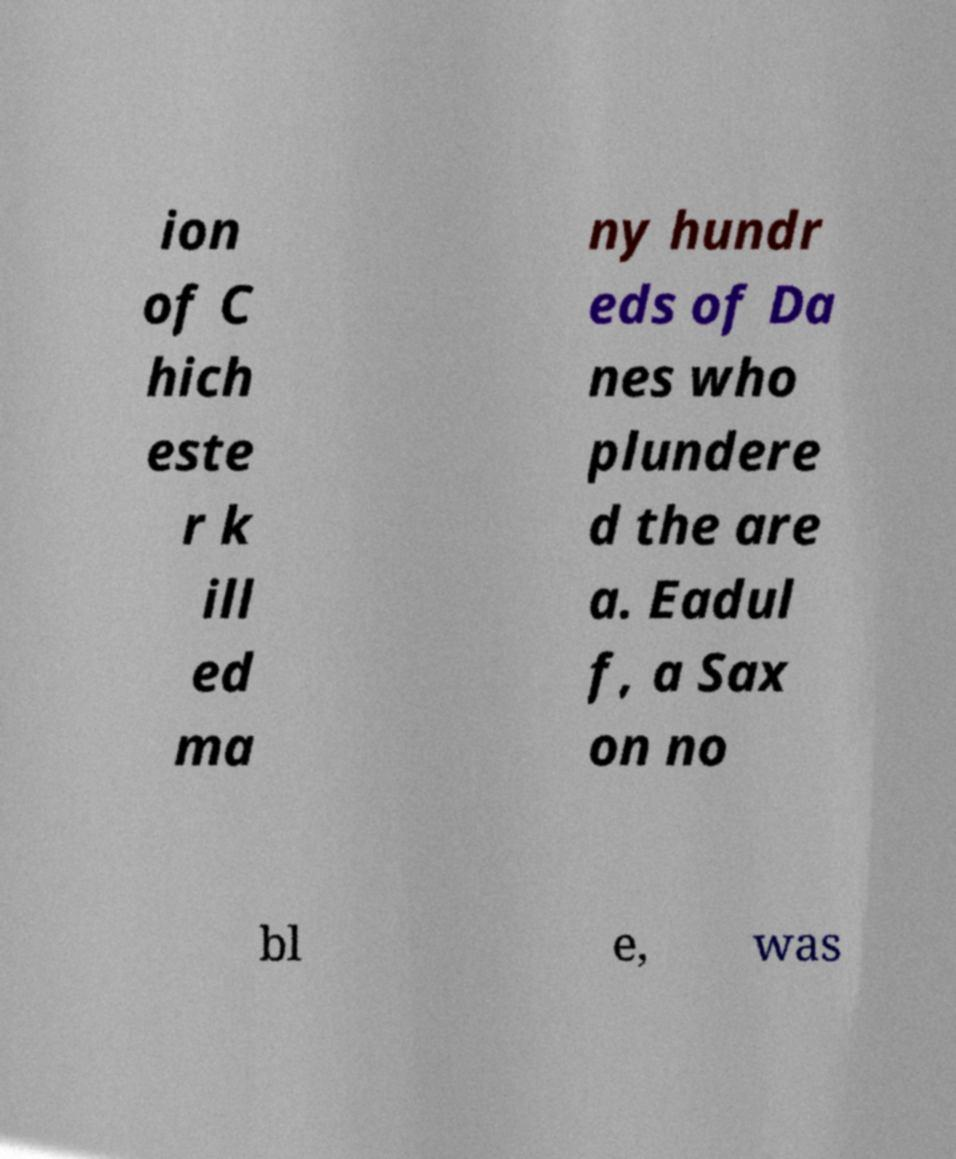I need the written content from this picture converted into text. Can you do that? ion of C hich este r k ill ed ma ny hundr eds of Da nes who plundere d the are a. Eadul f, a Sax on no bl e, was 